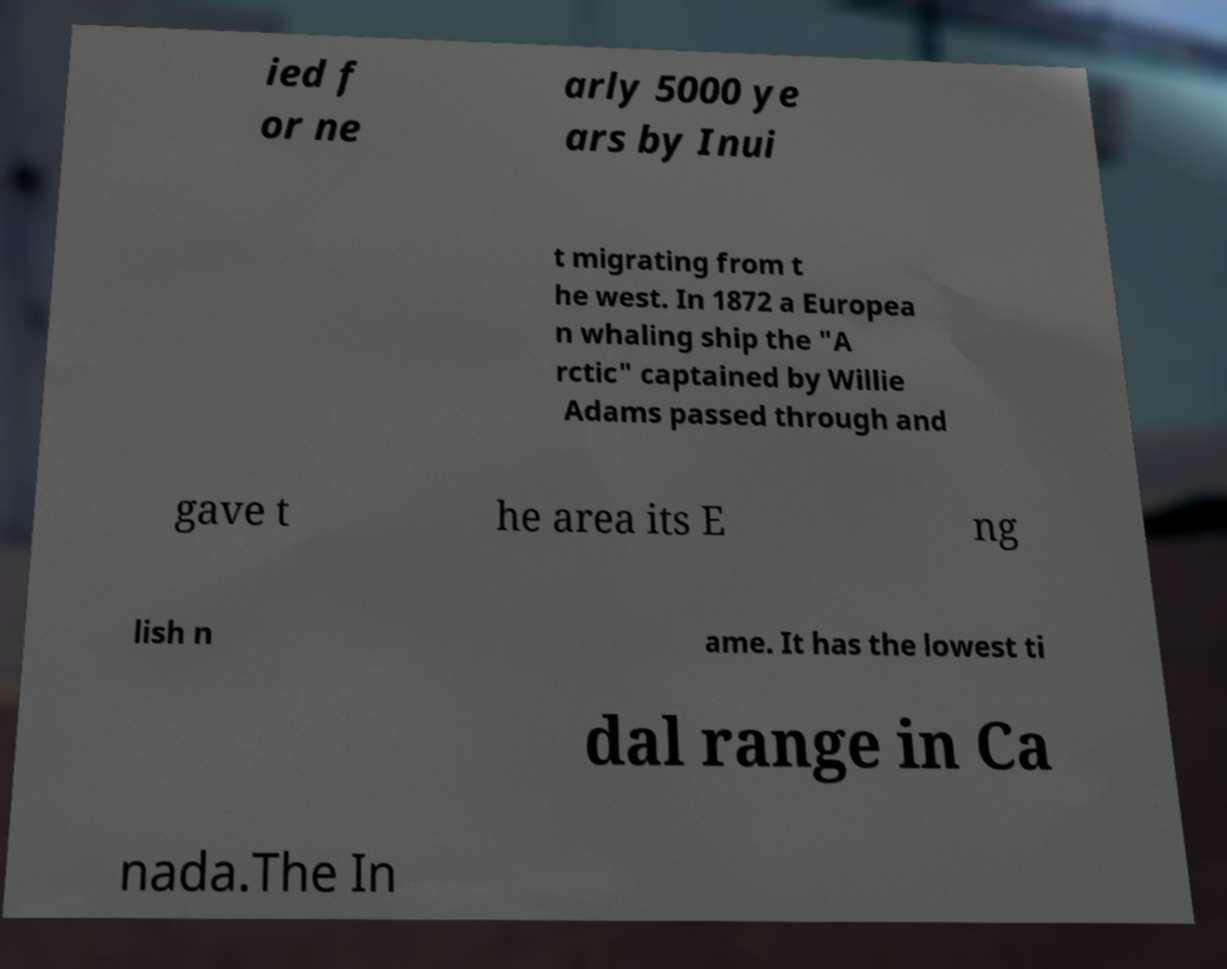Can you accurately transcribe the text from the provided image for me? ied f or ne arly 5000 ye ars by Inui t migrating from t he west. In 1872 a Europea n whaling ship the "A rctic" captained by Willie Adams passed through and gave t he area its E ng lish n ame. It has the lowest ti dal range in Ca nada.The In 